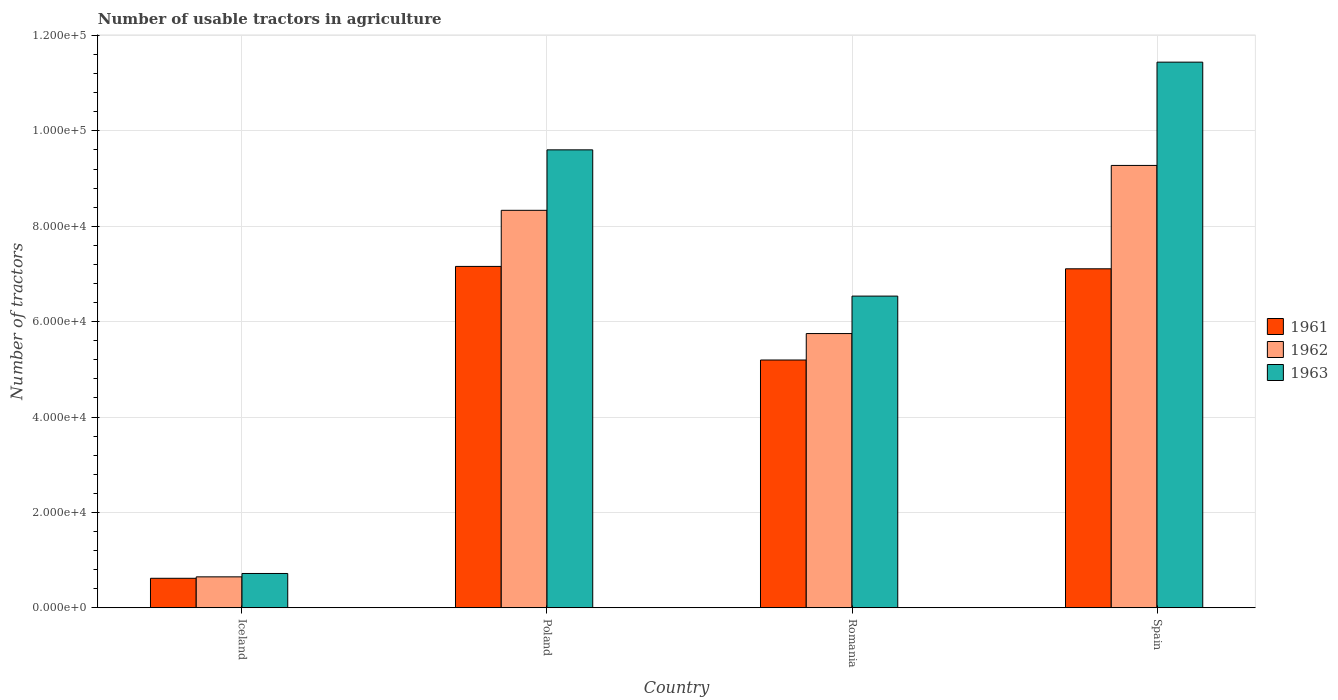How many groups of bars are there?
Your response must be concise. 4. Are the number of bars per tick equal to the number of legend labels?
Make the answer very short. Yes. Are the number of bars on each tick of the X-axis equal?
Your response must be concise. Yes. In how many cases, is the number of bars for a given country not equal to the number of legend labels?
Give a very brief answer. 0. What is the number of usable tractors in agriculture in 1961 in Romania?
Provide a short and direct response. 5.20e+04. Across all countries, what is the maximum number of usable tractors in agriculture in 1963?
Ensure brevity in your answer.  1.14e+05. Across all countries, what is the minimum number of usable tractors in agriculture in 1962?
Provide a succinct answer. 6479. In which country was the number of usable tractors in agriculture in 1961 minimum?
Your answer should be very brief. Iceland. What is the total number of usable tractors in agriculture in 1961 in the graph?
Your answer should be very brief. 2.01e+05. What is the difference between the number of usable tractors in agriculture in 1961 in Poland and that in Romania?
Your answer should be compact. 1.96e+04. What is the difference between the number of usable tractors in agriculture in 1961 in Spain and the number of usable tractors in agriculture in 1963 in Romania?
Your answer should be very brief. 5726. What is the average number of usable tractors in agriculture in 1963 per country?
Your answer should be very brief. 7.07e+04. What is the difference between the number of usable tractors in agriculture of/in 1963 and number of usable tractors in agriculture of/in 1961 in Poland?
Ensure brevity in your answer.  2.44e+04. What is the ratio of the number of usable tractors in agriculture in 1963 in Iceland to that in Poland?
Your answer should be compact. 0.07. Is the number of usable tractors in agriculture in 1962 in Poland less than that in Romania?
Give a very brief answer. No. Is the difference between the number of usable tractors in agriculture in 1963 in Iceland and Spain greater than the difference between the number of usable tractors in agriculture in 1961 in Iceland and Spain?
Your response must be concise. No. What is the difference between the highest and the second highest number of usable tractors in agriculture in 1961?
Ensure brevity in your answer.  -1.96e+04. What is the difference between the highest and the lowest number of usable tractors in agriculture in 1962?
Provide a succinct answer. 8.63e+04. In how many countries, is the number of usable tractors in agriculture in 1961 greater than the average number of usable tractors in agriculture in 1961 taken over all countries?
Make the answer very short. 3. What does the 3rd bar from the right in Poland represents?
Your answer should be compact. 1961. How many bars are there?
Offer a very short reply. 12. How many countries are there in the graph?
Offer a terse response. 4. What is the difference between two consecutive major ticks on the Y-axis?
Provide a succinct answer. 2.00e+04. How are the legend labels stacked?
Your answer should be compact. Vertical. What is the title of the graph?
Offer a very short reply. Number of usable tractors in agriculture. Does "1965" appear as one of the legend labels in the graph?
Make the answer very short. No. What is the label or title of the Y-axis?
Keep it short and to the point. Number of tractors. What is the Number of tractors of 1961 in Iceland?
Your answer should be compact. 6177. What is the Number of tractors in 1962 in Iceland?
Provide a short and direct response. 6479. What is the Number of tractors in 1963 in Iceland?
Keep it short and to the point. 7187. What is the Number of tractors of 1961 in Poland?
Your answer should be compact. 7.16e+04. What is the Number of tractors in 1962 in Poland?
Your answer should be compact. 8.33e+04. What is the Number of tractors in 1963 in Poland?
Make the answer very short. 9.60e+04. What is the Number of tractors in 1961 in Romania?
Make the answer very short. 5.20e+04. What is the Number of tractors of 1962 in Romania?
Provide a succinct answer. 5.75e+04. What is the Number of tractors of 1963 in Romania?
Provide a short and direct response. 6.54e+04. What is the Number of tractors of 1961 in Spain?
Your answer should be very brief. 7.11e+04. What is the Number of tractors in 1962 in Spain?
Give a very brief answer. 9.28e+04. What is the Number of tractors in 1963 in Spain?
Offer a very short reply. 1.14e+05. Across all countries, what is the maximum Number of tractors of 1961?
Provide a short and direct response. 7.16e+04. Across all countries, what is the maximum Number of tractors in 1962?
Your response must be concise. 9.28e+04. Across all countries, what is the maximum Number of tractors of 1963?
Provide a succinct answer. 1.14e+05. Across all countries, what is the minimum Number of tractors of 1961?
Keep it short and to the point. 6177. Across all countries, what is the minimum Number of tractors of 1962?
Make the answer very short. 6479. Across all countries, what is the minimum Number of tractors of 1963?
Offer a very short reply. 7187. What is the total Number of tractors in 1961 in the graph?
Offer a very short reply. 2.01e+05. What is the total Number of tractors of 1962 in the graph?
Your response must be concise. 2.40e+05. What is the total Number of tractors in 1963 in the graph?
Your response must be concise. 2.83e+05. What is the difference between the Number of tractors of 1961 in Iceland and that in Poland?
Give a very brief answer. -6.54e+04. What is the difference between the Number of tractors of 1962 in Iceland and that in Poland?
Give a very brief answer. -7.69e+04. What is the difference between the Number of tractors in 1963 in Iceland and that in Poland?
Provide a short and direct response. -8.88e+04. What is the difference between the Number of tractors of 1961 in Iceland and that in Romania?
Your response must be concise. -4.58e+04. What is the difference between the Number of tractors of 1962 in Iceland and that in Romania?
Your answer should be compact. -5.10e+04. What is the difference between the Number of tractors of 1963 in Iceland and that in Romania?
Offer a terse response. -5.82e+04. What is the difference between the Number of tractors in 1961 in Iceland and that in Spain?
Keep it short and to the point. -6.49e+04. What is the difference between the Number of tractors in 1962 in Iceland and that in Spain?
Provide a short and direct response. -8.63e+04. What is the difference between the Number of tractors in 1963 in Iceland and that in Spain?
Give a very brief answer. -1.07e+05. What is the difference between the Number of tractors of 1961 in Poland and that in Romania?
Offer a very short reply. 1.96e+04. What is the difference between the Number of tractors in 1962 in Poland and that in Romania?
Your response must be concise. 2.58e+04. What is the difference between the Number of tractors in 1963 in Poland and that in Romania?
Ensure brevity in your answer.  3.07e+04. What is the difference between the Number of tractors in 1962 in Poland and that in Spain?
Your response must be concise. -9414. What is the difference between the Number of tractors in 1963 in Poland and that in Spain?
Ensure brevity in your answer.  -1.84e+04. What is the difference between the Number of tractors in 1961 in Romania and that in Spain?
Provide a succinct answer. -1.91e+04. What is the difference between the Number of tractors in 1962 in Romania and that in Spain?
Your answer should be compact. -3.53e+04. What is the difference between the Number of tractors in 1963 in Romania and that in Spain?
Offer a very short reply. -4.91e+04. What is the difference between the Number of tractors of 1961 in Iceland and the Number of tractors of 1962 in Poland?
Offer a very short reply. -7.72e+04. What is the difference between the Number of tractors in 1961 in Iceland and the Number of tractors in 1963 in Poland?
Offer a terse response. -8.98e+04. What is the difference between the Number of tractors of 1962 in Iceland and the Number of tractors of 1963 in Poland?
Provide a succinct answer. -8.95e+04. What is the difference between the Number of tractors of 1961 in Iceland and the Number of tractors of 1962 in Romania?
Your answer should be compact. -5.13e+04. What is the difference between the Number of tractors of 1961 in Iceland and the Number of tractors of 1963 in Romania?
Keep it short and to the point. -5.92e+04. What is the difference between the Number of tractors in 1962 in Iceland and the Number of tractors in 1963 in Romania?
Keep it short and to the point. -5.89e+04. What is the difference between the Number of tractors in 1961 in Iceland and the Number of tractors in 1962 in Spain?
Offer a terse response. -8.66e+04. What is the difference between the Number of tractors in 1961 in Iceland and the Number of tractors in 1963 in Spain?
Offer a very short reply. -1.08e+05. What is the difference between the Number of tractors in 1962 in Iceland and the Number of tractors in 1963 in Spain?
Ensure brevity in your answer.  -1.08e+05. What is the difference between the Number of tractors of 1961 in Poland and the Number of tractors of 1962 in Romania?
Your response must be concise. 1.41e+04. What is the difference between the Number of tractors in 1961 in Poland and the Number of tractors in 1963 in Romania?
Ensure brevity in your answer.  6226. What is the difference between the Number of tractors of 1962 in Poland and the Number of tractors of 1963 in Romania?
Keep it short and to the point. 1.80e+04. What is the difference between the Number of tractors in 1961 in Poland and the Number of tractors in 1962 in Spain?
Your answer should be very brief. -2.12e+04. What is the difference between the Number of tractors in 1961 in Poland and the Number of tractors in 1963 in Spain?
Offer a terse response. -4.28e+04. What is the difference between the Number of tractors in 1962 in Poland and the Number of tractors in 1963 in Spain?
Keep it short and to the point. -3.11e+04. What is the difference between the Number of tractors in 1961 in Romania and the Number of tractors in 1962 in Spain?
Offer a terse response. -4.08e+04. What is the difference between the Number of tractors in 1961 in Romania and the Number of tractors in 1963 in Spain?
Offer a terse response. -6.25e+04. What is the difference between the Number of tractors in 1962 in Romania and the Number of tractors in 1963 in Spain?
Make the answer very short. -5.69e+04. What is the average Number of tractors of 1961 per country?
Offer a terse response. 5.02e+04. What is the average Number of tractors of 1962 per country?
Your answer should be very brief. 6.00e+04. What is the average Number of tractors of 1963 per country?
Provide a succinct answer. 7.07e+04. What is the difference between the Number of tractors in 1961 and Number of tractors in 1962 in Iceland?
Provide a succinct answer. -302. What is the difference between the Number of tractors of 1961 and Number of tractors of 1963 in Iceland?
Provide a short and direct response. -1010. What is the difference between the Number of tractors in 1962 and Number of tractors in 1963 in Iceland?
Your answer should be compact. -708. What is the difference between the Number of tractors of 1961 and Number of tractors of 1962 in Poland?
Give a very brief answer. -1.18e+04. What is the difference between the Number of tractors of 1961 and Number of tractors of 1963 in Poland?
Keep it short and to the point. -2.44e+04. What is the difference between the Number of tractors of 1962 and Number of tractors of 1963 in Poland?
Make the answer very short. -1.27e+04. What is the difference between the Number of tractors in 1961 and Number of tractors in 1962 in Romania?
Provide a short and direct response. -5548. What is the difference between the Number of tractors of 1961 and Number of tractors of 1963 in Romania?
Your answer should be very brief. -1.34e+04. What is the difference between the Number of tractors of 1962 and Number of tractors of 1963 in Romania?
Provide a short and direct response. -7851. What is the difference between the Number of tractors in 1961 and Number of tractors in 1962 in Spain?
Give a very brief answer. -2.17e+04. What is the difference between the Number of tractors in 1961 and Number of tractors in 1963 in Spain?
Keep it short and to the point. -4.33e+04. What is the difference between the Number of tractors of 1962 and Number of tractors of 1963 in Spain?
Provide a short and direct response. -2.17e+04. What is the ratio of the Number of tractors of 1961 in Iceland to that in Poland?
Make the answer very short. 0.09. What is the ratio of the Number of tractors in 1962 in Iceland to that in Poland?
Ensure brevity in your answer.  0.08. What is the ratio of the Number of tractors in 1963 in Iceland to that in Poland?
Offer a very short reply. 0.07. What is the ratio of the Number of tractors in 1961 in Iceland to that in Romania?
Provide a succinct answer. 0.12. What is the ratio of the Number of tractors in 1962 in Iceland to that in Romania?
Make the answer very short. 0.11. What is the ratio of the Number of tractors in 1963 in Iceland to that in Romania?
Give a very brief answer. 0.11. What is the ratio of the Number of tractors in 1961 in Iceland to that in Spain?
Your answer should be compact. 0.09. What is the ratio of the Number of tractors of 1962 in Iceland to that in Spain?
Provide a short and direct response. 0.07. What is the ratio of the Number of tractors in 1963 in Iceland to that in Spain?
Your response must be concise. 0.06. What is the ratio of the Number of tractors of 1961 in Poland to that in Romania?
Provide a short and direct response. 1.38. What is the ratio of the Number of tractors of 1962 in Poland to that in Romania?
Offer a very short reply. 1.45. What is the ratio of the Number of tractors of 1963 in Poland to that in Romania?
Provide a short and direct response. 1.47. What is the ratio of the Number of tractors of 1961 in Poland to that in Spain?
Give a very brief answer. 1.01. What is the ratio of the Number of tractors in 1962 in Poland to that in Spain?
Provide a short and direct response. 0.9. What is the ratio of the Number of tractors of 1963 in Poland to that in Spain?
Keep it short and to the point. 0.84. What is the ratio of the Number of tractors in 1961 in Romania to that in Spain?
Your response must be concise. 0.73. What is the ratio of the Number of tractors of 1962 in Romania to that in Spain?
Provide a short and direct response. 0.62. What is the ratio of the Number of tractors in 1963 in Romania to that in Spain?
Offer a terse response. 0.57. What is the difference between the highest and the second highest Number of tractors in 1962?
Provide a succinct answer. 9414. What is the difference between the highest and the second highest Number of tractors in 1963?
Your response must be concise. 1.84e+04. What is the difference between the highest and the lowest Number of tractors in 1961?
Give a very brief answer. 6.54e+04. What is the difference between the highest and the lowest Number of tractors in 1962?
Your answer should be very brief. 8.63e+04. What is the difference between the highest and the lowest Number of tractors of 1963?
Provide a short and direct response. 1.07e+05. 